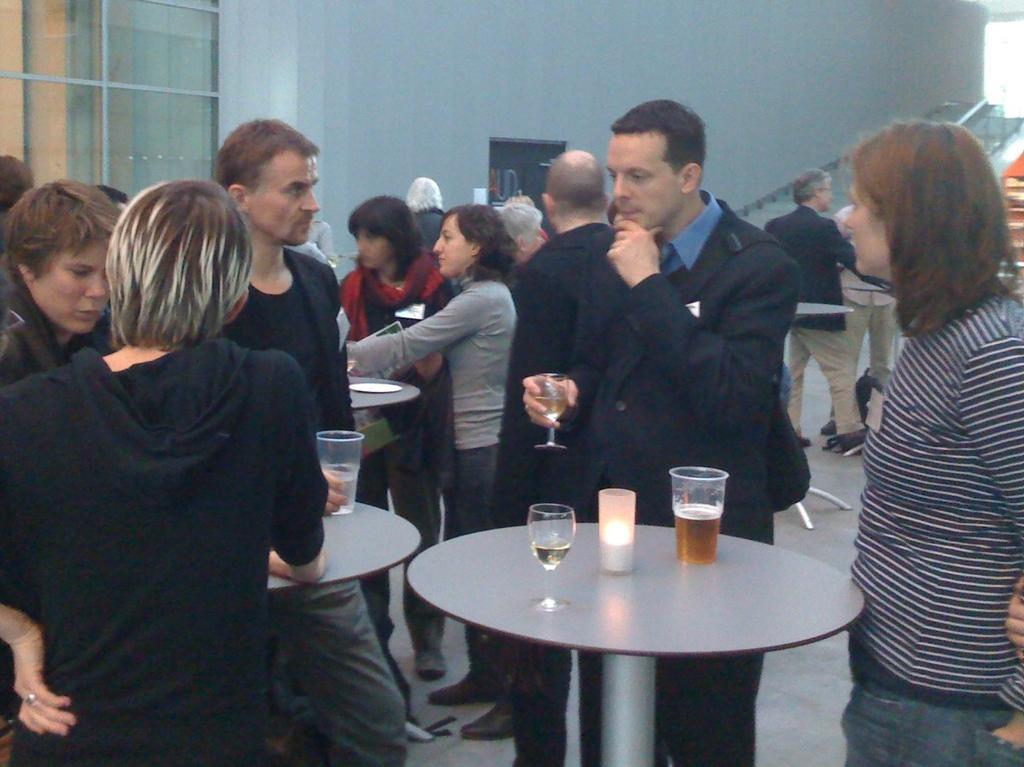Please provide a concise description of this image. In the image we can see there are people who are standing and a person is holding wine glass in his hand. 